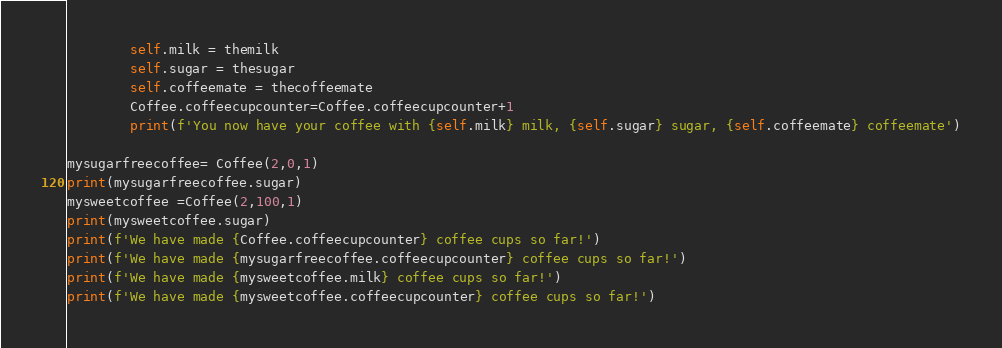<code> <loc_0><loc_0><loc_500><loc_500><_Python_>        self.milk = themilk
        self.sugar = thesugar
        self.coffeemate = thecoffeemate
        Coffee.coffeecupcounter=Coffee.coffeecupcounter+1
        print(f'You now have your coffee with {self.milk} milk, {self.sugar} sugar, {self.coffeemate} coffeemate')

mysugarfreecoffee= Coffee(2,0,1)
print(mysugarfreecoffee.sugar)
mysweetcoffee =Coffee(2,100,1)
print(mysweetcoffee.sugar)
print(f'We have made {Coffee.coffeecupcounter} coffee cups so far!')
print(f'We have made {mysugarfreecoffee.coffeecupcounter} coffee cups so far!')
print(f'We have made {mysweetcoffee.milk} coffee cups so far!')
print(f'We have made {mysweetcoffee.coffeecupcounter} coffee cups so far!')</code> 